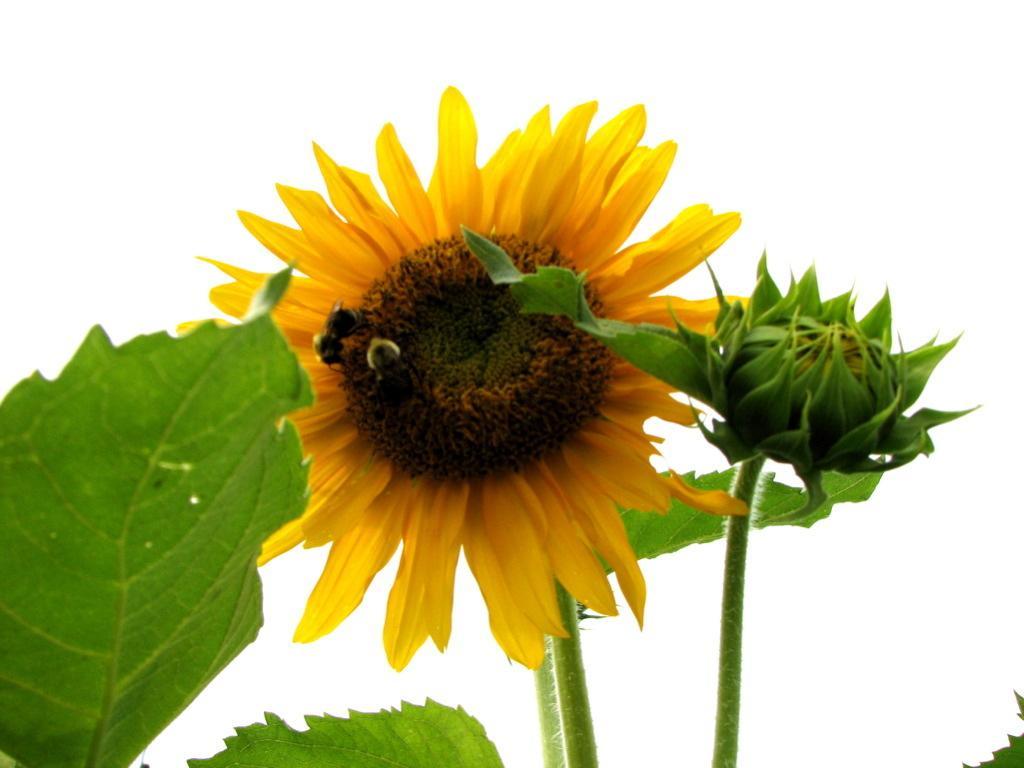Please provide a concise description of this image. In this image we can see an insect on the flower. We can also see a bud to the stem of a plant and some leaves beside it. 